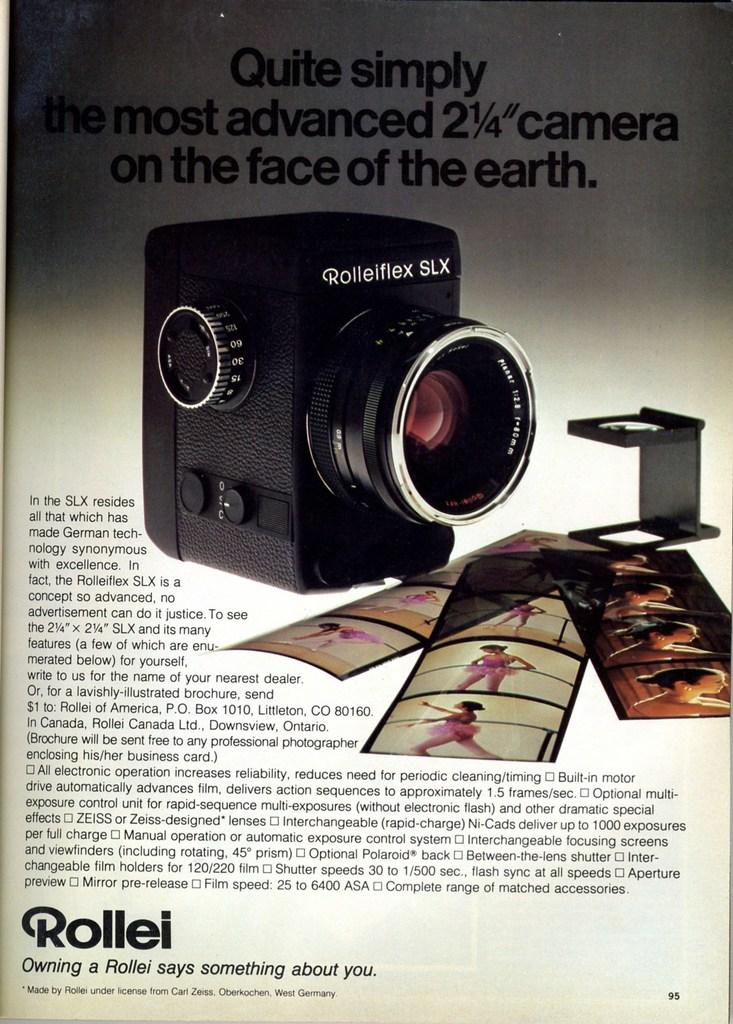What is featured in the picture in the image? There is a poster in the picture. What can be found on the poster? The poster has text on it and a picture of a camera. Are there any other items visible in the picture? Yes, there are photographs visible in the picture. How does the growth of the coil affect the airplane in the image? There is no growth, coil, or airplane present in the image. 